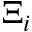<formula> <loc_0><loc_0><loc_500><loc_500>\Xi _ { i }</formula> 